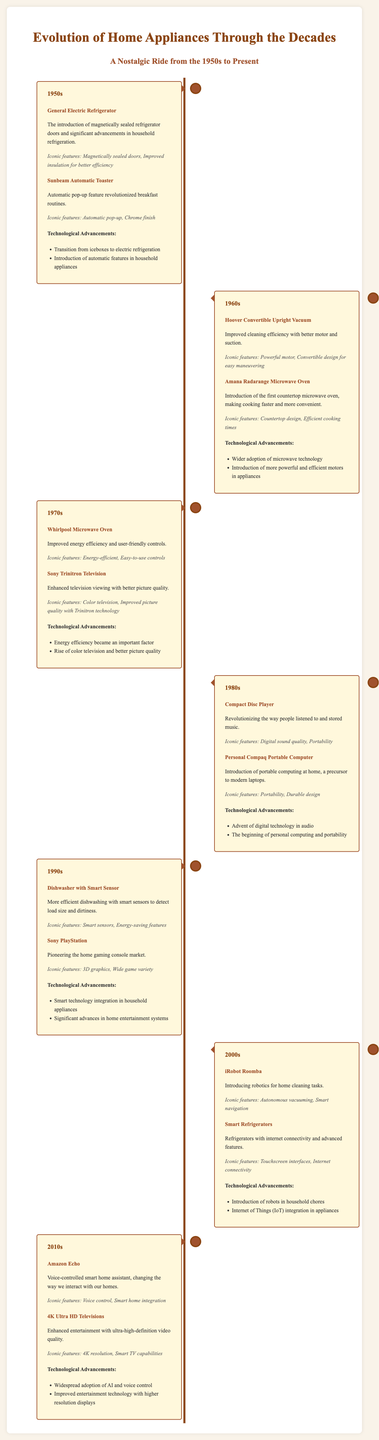what appliance introduced in the 1950s featured a magnetically sealed door? The document mentions the General Electric Refrigerator as the appliance with a magnetically sealed door introduced in the 1950s.
Answer: General Electric Refrigerator which appliance from the 1980s is noted for its digital sound quality? The Compact Disc Player from the 1980s is highlighted for its digital sound quality.
Answer: Compact Disc Player what decade saw the introduction of the first countertop microwave oven? The Amana Radarange Microwave Oven, the first countertop microwave oven, was introduced in the 1960s.
Answer: 1960s how did the technological advancements in the 1990s differ from those in the 2000s? The 1990s focused on smart technology integration in appliances, while the 2000s introduced robots in household chores and IoT integration.
Answer: Different advancements in technology which appliance revolutionized home cleaning tasks in the 2000s? The iRobot Roomba is noted for introducing robotics for home cleaning tasks during the 2000s.
Answer: iRobot Roomba 